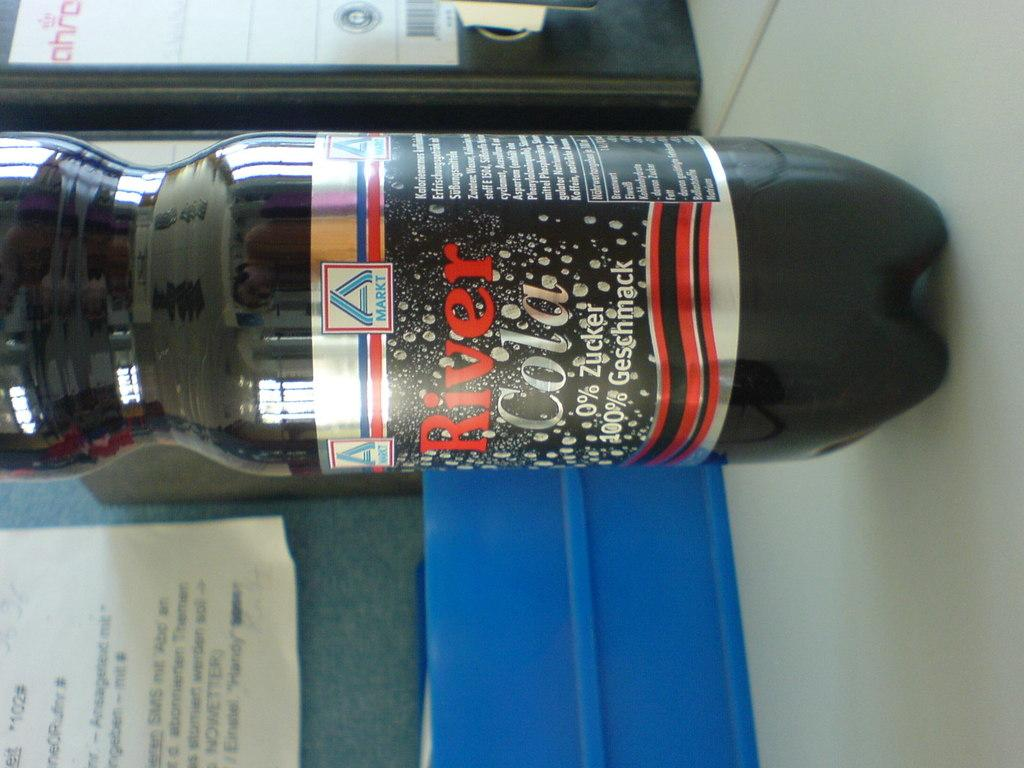<image>
Render a clear and concise summary of the photo. A full bottle of RIver Cola which includes percentages on the label. 